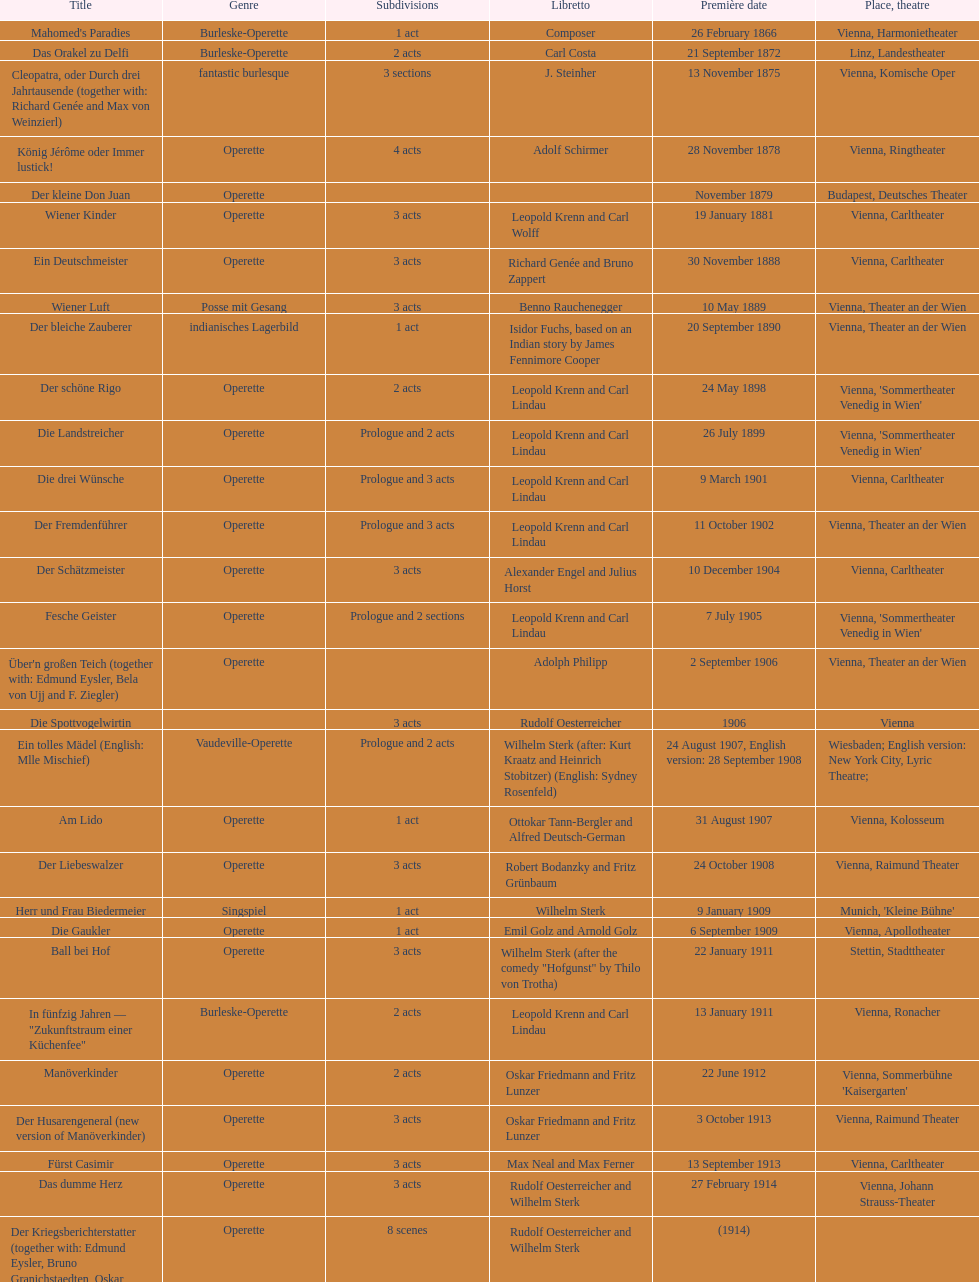What was the total count of 1 acts? 5. 